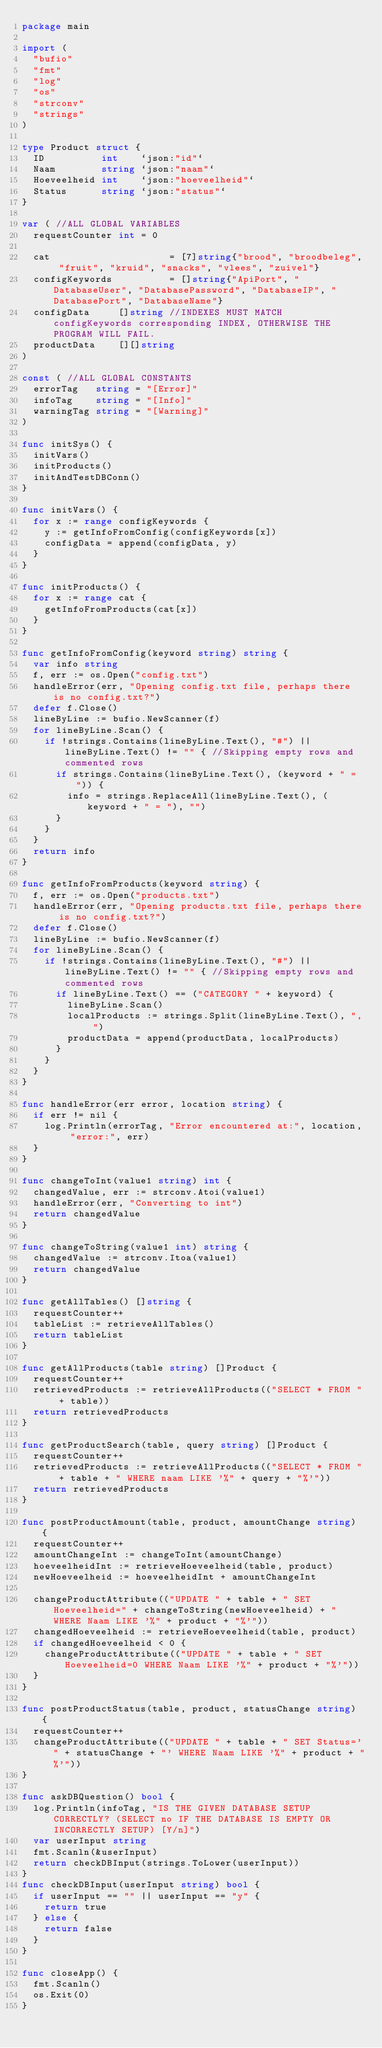<code> <loc_0><loc_0><loc_500><loc_500><_Go_>package main

import (
	"bufio"
	"fmt"
	"log"
	"os"
	"strconv"
	"strings"
)

type Product struct {
	ID          int    `json:"id"`
	Naam        string `json:"naam"`
	Hoeveelheid int    `json:"hoeveelheid"`
	Status      string `json:"status"`
}

var ( //ALL GLOBAL VARIABLES
	requestCounter int = 0

	cat                     = [7]string{"brood", "broodbeleg", "fruit", "kruid", "snacks", "vlees", "zuivel"}
	configKeywords          = []string{"ApiPort", "DatabaseUser", "DatabasePassword", "DatabaseIP", "DatabasePort", "DatabaseName"}
	configData     []string //INDEXES MUST MATCH configKeywords corresponding INDEX, OTHERWISE THE PROGRAM WILL FAIL.
	productData    [][]string
)

const ( //ALL GLOBAL CONSTANTS
	errorTag   string = "[Error]"
	infoTag    string = "[Info]"
	warningTag string = "[Warning]"
)

func initSys() {
	initVars()
	initProducts()
	initAndTestDBConn()
}

func initVars() {
	for x := range configKeywords {
		y := getInfoFromConfig(configKeywords[x])
		configData = append(configData, y)
	}
}

func initProducts() {
	for x := range cat {
		getInfoFromProducts(cat[x])
	}
}

func getInfoFromConfig(keyword string) string {
	var info string
	f, err := os.Open("config.txt")
	handleError(err, "Opening config.txt file, perhaps there is no config.txt?")
	defer f.Close()
	lineByLine := bufio.NewScanner(f)
	for lineByLine.Scan() {
		if !strings.Contains(lineByLine.Text(), "#") || lineByLine.Text() != "" { //Skipping empty rows and commented rows
			if strings.Contains(lineByLine.Text(), (keyword + " = ")) {
				info = strings.ReplaceAll(lineByLine.Text(), (keyword + " = "), "")
			}
		}
	}
	return info
}

func getInfoFromProducts(keyword string) {
	f, err := os.Open("products.txt")
	handleError(err, "Opening products.txt file, perhaps there is no config.txt?")
	defer f.Close()
	lineByLine := bufio.NewScanner(f)
	for lineByLine.Scan() {
		if !strings.Contains(lineByLine.Text(), "#") || lineByLine.Text() != "" { //Skipping empty rows and commented rows
			if lineByLine.Text() == ("CATEGORY " + keyword) {
				lineByLine.Scan()
				localProducts := strings.Split(lineByLine.Text(), ", ")
				productData = append(productData, localProducts)
			}
		}
	}
}

func handleError(err error, location string) {
	if err != nil {
		log.Println(errorTag, "Error encountered at:", location, "error:", err)
	}
}

func changeToInt(value1 string) int {
	changedValue, err := strconv.Atoi(value1)
	handleError(err, "Converting to int")
	return changedValue
}

func changeToString(value1 int) string {
	changedValue := strconv.Itoa(value1)
	return changedValue
}

func getAllTables() []string {
	requestCounter++
	tableList := retrieveAllTables()
	return tableList
}

func getAllProducts(table string) []Product {
	requestCounter++
	retrievedProducts := retrieveAllProducts(("SELECT * FROM " + table))
	return retrievedProducts
}

func getProductSearch(table, query string) []Product {
	requestCounter++
	retrievedProducts := retrieveAllProducts(("SELECT * FROM " + table + " WHERE naam LIKE '%" + query + "%'"))
	return retrievedProducts
}

func postProductAmount(table, product, amountChange string) {
	requestCounter++
	amountChangeInt := changeToInt(amountChange)
	hoeveelheidInt := retrieveHoeveelheid(table, product)
	newHoeveelheid := hoeveelheidInt + amountChangeInt

	changeProductAttribute(("UPDATE " + table + " SET Hoeveelheid=" + changeToString(newHoeveelheid) + " WHERE Naam LIKE '%" + product + "%'"))
	changedHoeveelheid := retrieveHoeveelheid(table, product)
	if changedHoeveelheid < 0 {
		changeProductAttribute(("UPDATE " + table + " SET Hoeveelheid=0 WHERE Naam LIKE '%" + product + "%'"))
	}
}

func postProductStatus(table, product, statusChange string) {
	requestCounter++
	changeProductAttribute(("UPDATE " + table + " SET Status='" + statusChange + "' WHERE Naam LIKE '%" + product + "%'"))
}

func askDBQuestion() bool {
	log.Println(infoTag, "IS THE GIVEN DATABASE SETUP CORRECTLY? (SELECT no IF THE DATABASE IS EMPTY OR INCORRECTLY SETUP) [Y/n]")
	var userInput string
	fmt.Scanln(&userInput)
	return checkDBInput(strings.ToLower(userInput))
}
func checkDBInput(userInput string) bool {
	if userInput == "" || userInput == "y" {
		return true
	} else {
		return false
	}
}

func closeApp() {
	fmt.Scanln()
	os.Exit(0)
}
</code> 